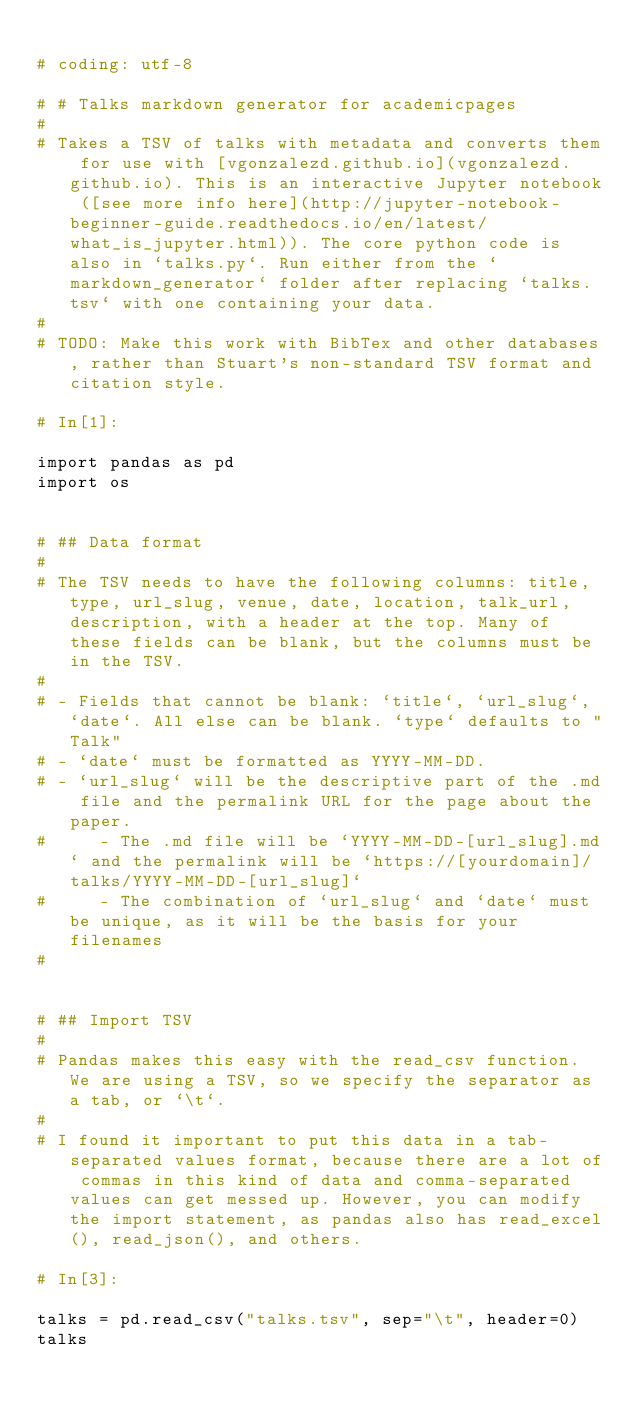Convert code to text. <code><loc_0><loc_0><loc_500><loc_500><_Python_>
# coding: utf-8

# # Talks markdown generator for academicpages
# 
# Takes a TSV of talks with metadata and converts them for use with [vgonzalezd.github.io](vgonzalezd.github.io). This is an interactive Jupyter notebook ([see more info here](http://jupyter-notebook-beginner-guide.readthedocs.io/en/latest/what_is_jupyter.html)). The core python code is also in `talks.py`. Run either from the `markdown_generator` folder after replacing `talks.tsv` with one containing your data.
# 
# TODO: Make this work with BibTex and other databases, rather than Stuart's non-standard TSV format and citation style.

# In[1]:

import pandas as pd
import os


# ## Data format
# 
# The TSV needs to have the following columns: title, type, url_slug, venue, date, location, talk_url, description, with a header at the top. Many of these fields can be blank, but the columns must be in the TSV.
# 
# - Fields that cannot be blank: `title`, `url_slug`, `date`. All else can be blank. `type` defaults to "Talk" 
# - `date` must be formatted as YYYY-MM-DD.
# - `url_slug` will be the descriptive part of the .md file and the permalink URL for the page about the paper. 
#     - The .md file will be `YYYY-MM-DD-[url_slug].md` and the permalink will be `https://[yourdomain]/talks/YYYY-MM-DD-[url_slug]`
#     - The combination of `url_slug` and `date` must be unique, as it will be the basis for your filenames
# 


# ## Import TSV
# 
# Pandas makes this easy with the read_csv function. We are using a TSV, so we specify the separator as a tab, or `\t`.
# 
# I found it important to put this data in a tab-separated values format, because there are a lot of commas in this kind of data and comma-separated values can get messed up. However, you can modify the import statement, as pandas also has read_excel(), read_json(), and others.

# In[3]:

talks = pd.read_csv("talks.tsv", sep="\t", header=0)
talks

</code> 